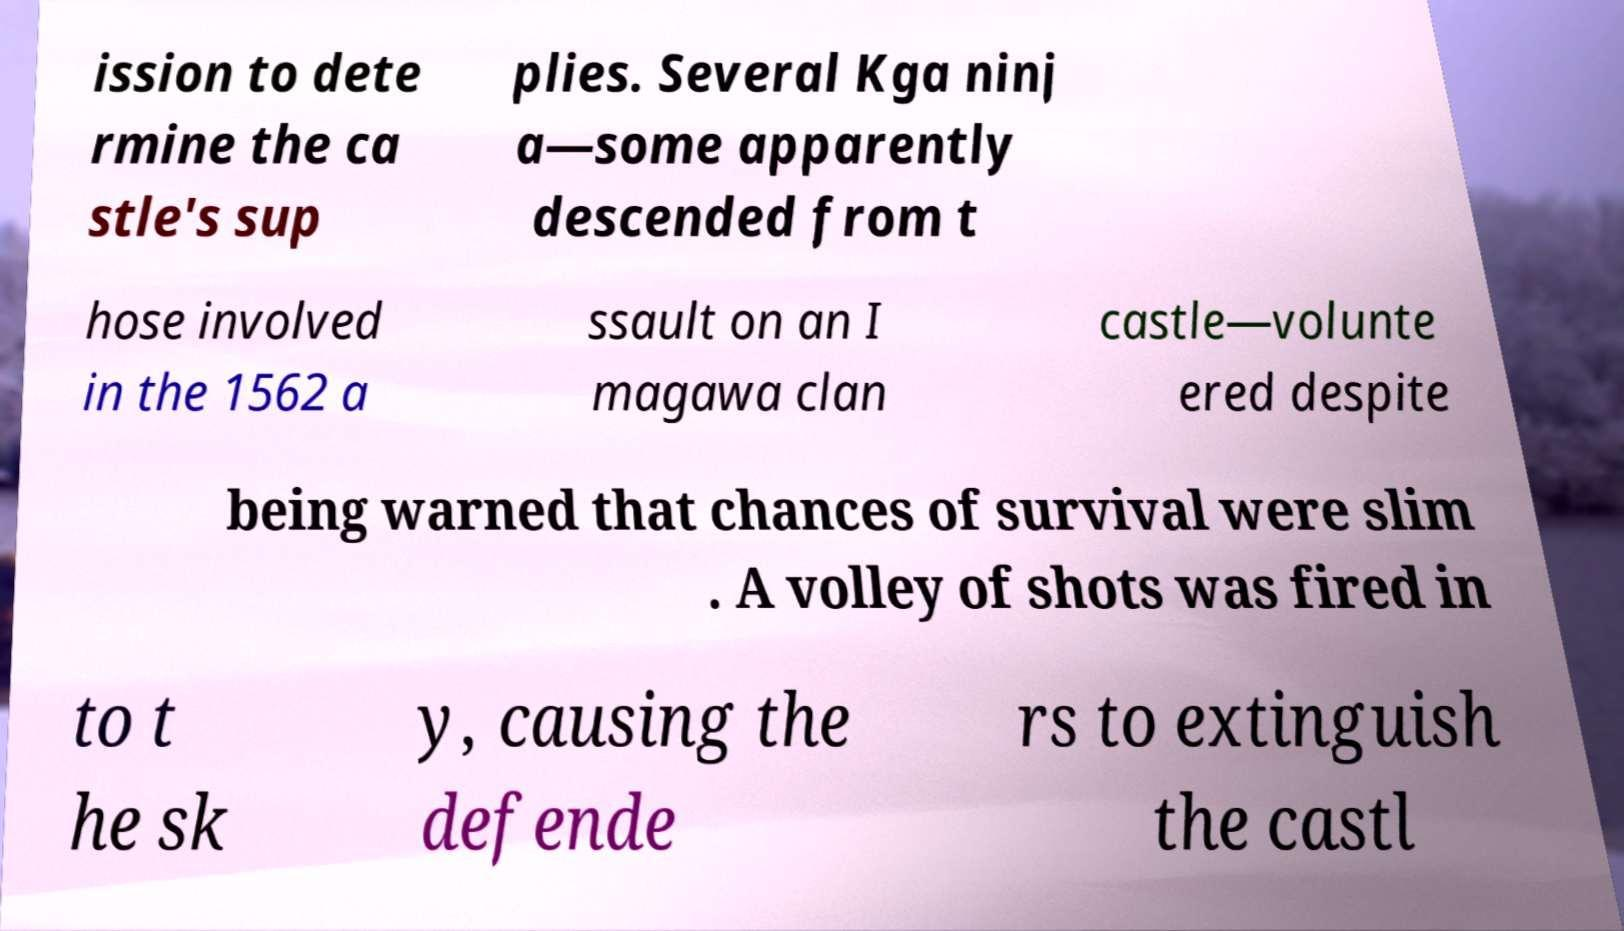For documentation purposes, I need the text within this image transcribed. Could you provide that? ission to dete rmine the ca stle's sup plies. Several Kga ninj a—some apparently descended from t hose involved in the 1562 a ssault on an I magawa clan castle—volunte ered despite being warned that chances of survival were slim . A volley of shots was fired in to t he sk y, causing the defende rs to extinguish the castl 